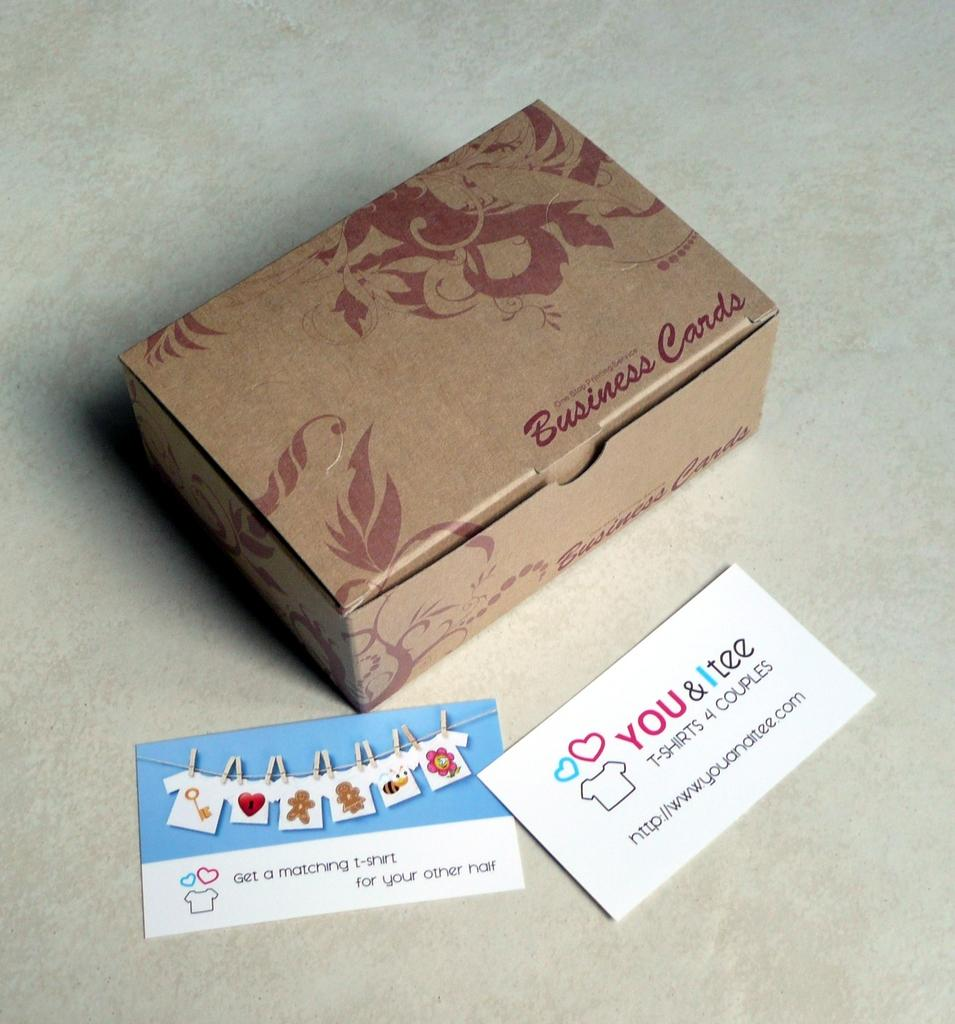<image>
Write a terse but informative summary of the picture. a small cardboard box with the words 'business cards' on the bottom right corner 